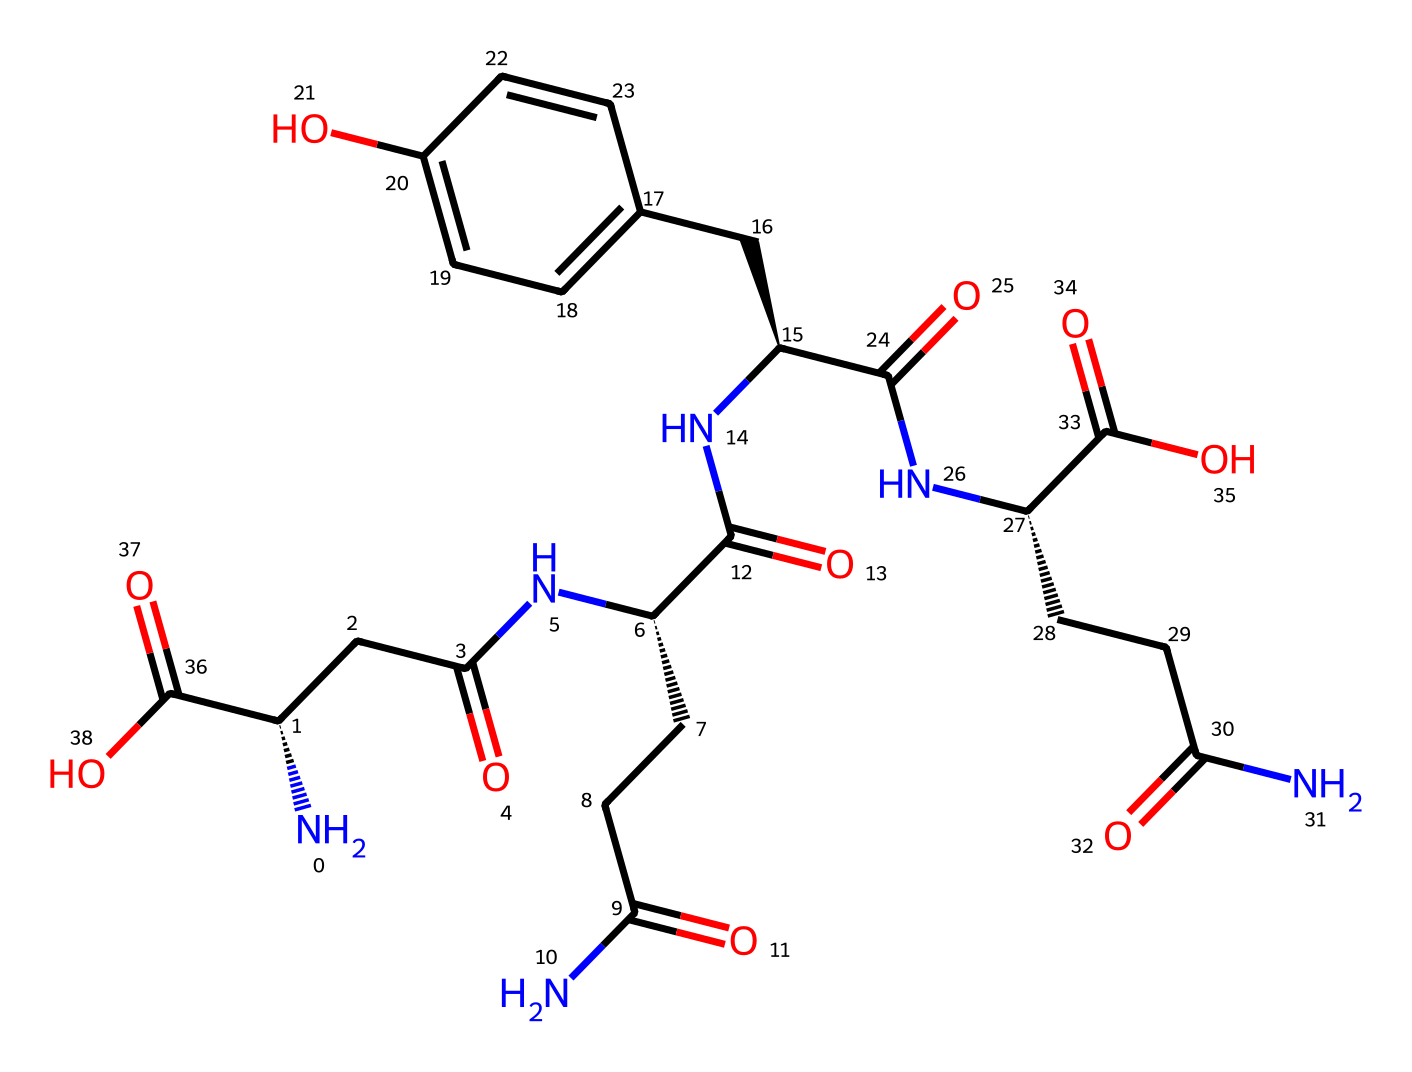What is the total number of nitrogen atoms in this chemical? By examining the SMILES representation, we see the presence of four nitrogen atoms marked by 'N' in the structure. These nitrogen atoms are typically involved in the formation of amide linkages, contributing to the overall properties of the fiber.
Answer: 4 How many carbon atoms are in the molecule? Counting the carbon atoms presented in the SMILES string reveals a total of 21 carbon atoms. Each 'C' represents a carbon atom, and taking into account the hydrocarbon structure, we tally them up.
Answer: 21 What functional groups are indicated in this chemical structure? The SMILES contains amide (–C(=O)N–) and carboxylic acid (–C(=O)O) functional groups. The presence of these groups can be inferred from the 'C(=O)' portion followed by 'N' and 'O'. Together, they indicate that this molecule has properties related to protein structure due to these functional groups.
Answer: amide and carboxylic acid Which part of the structure suggests its role as a fiber? The repetitive nature of the amide linkages (highlighted by multiple instances of 'N[C@@H]') implies that this structure is likely fibrous. This highlights the role of the protein structure specifically in providing tensile strength typical of silk fibers.
Answer: amide linkages How many rings are present in the chemical structure? The chemical structure does not present any rings; therefore, upon analyzing the provided SMILES, it is clear that there are no cyclic structures or closed loops, showing a linear composition.
Answer: 0 What is the significance of the chiral centers indicated in the structure? The presence of multiple chiral centers indicated by '[C@@H]' suggests that this molecule has stereoisomerism, which can affect the physical properties of the silk, including its strength and elasticity. These chiral centers govern the specific spatial arrangement of atoms affecting how the fibers pack and function.
Answer: stereoisomerism 